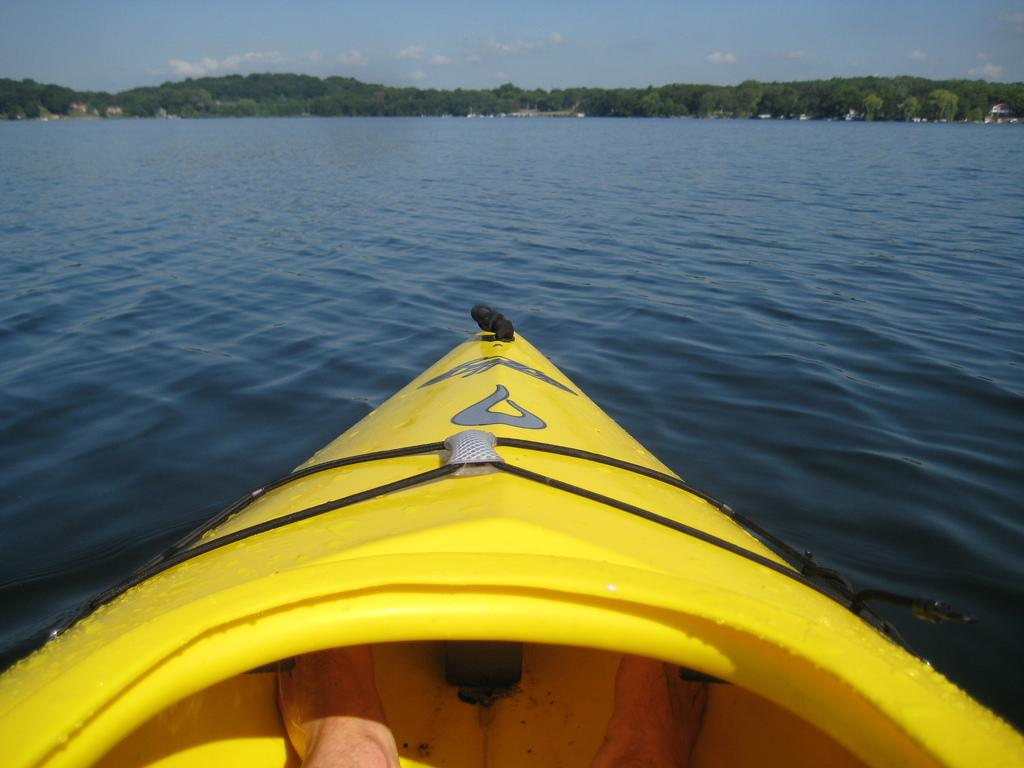What is the main subject of the image? There is a person in a boat in the image. What part of the person's body can be seen? The person's legs are visible. Where is the boat located? The boat is on the water. What can be seen in the background of the image? There are trees and the sky visible in the background of the image. What type of industry can be seen in the background of the image? There is no industry visible in the background of the image; it features trees and the sky. Can you tell me how many chins the person in the boat has? It is not possible to determine the number of chins the person in the boat has from the image. 